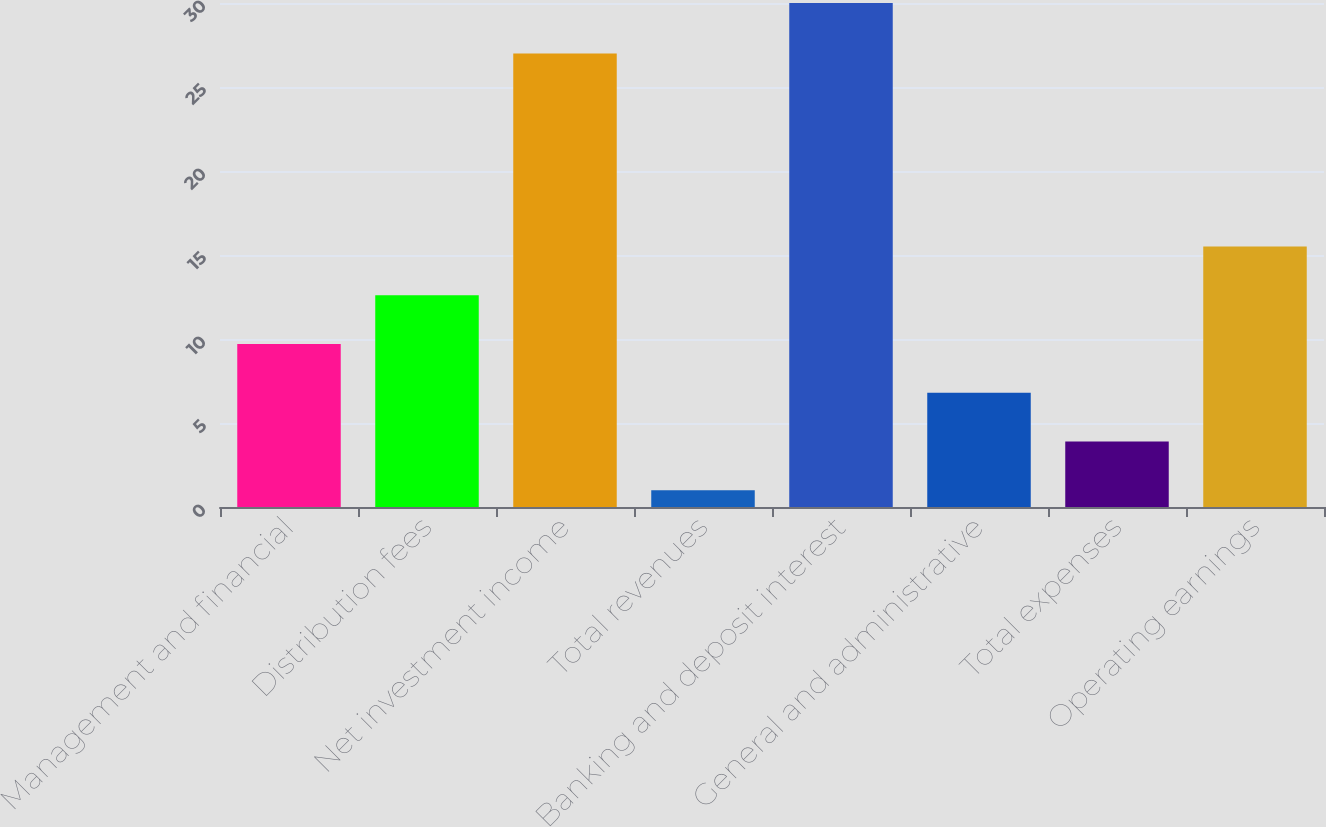Convert chart to OTSL. <chart><loc_0><loc_0><loc_500><loc_500><bar_chart><fcel>Management and financial<fcel>Distribution fees<fcel>Net investment income<fcel>Total revenues<fcel>Banking and deposit interest<fcel>General and administrative<fcel>Total expenses<fcel>Operating earnings<nl><fcel>9.7<fcel>12.6<fcel>27<fcel>1<fcel>30<fcel>6.8<fcel>3.9<fcel>15.5<nl></chart> 